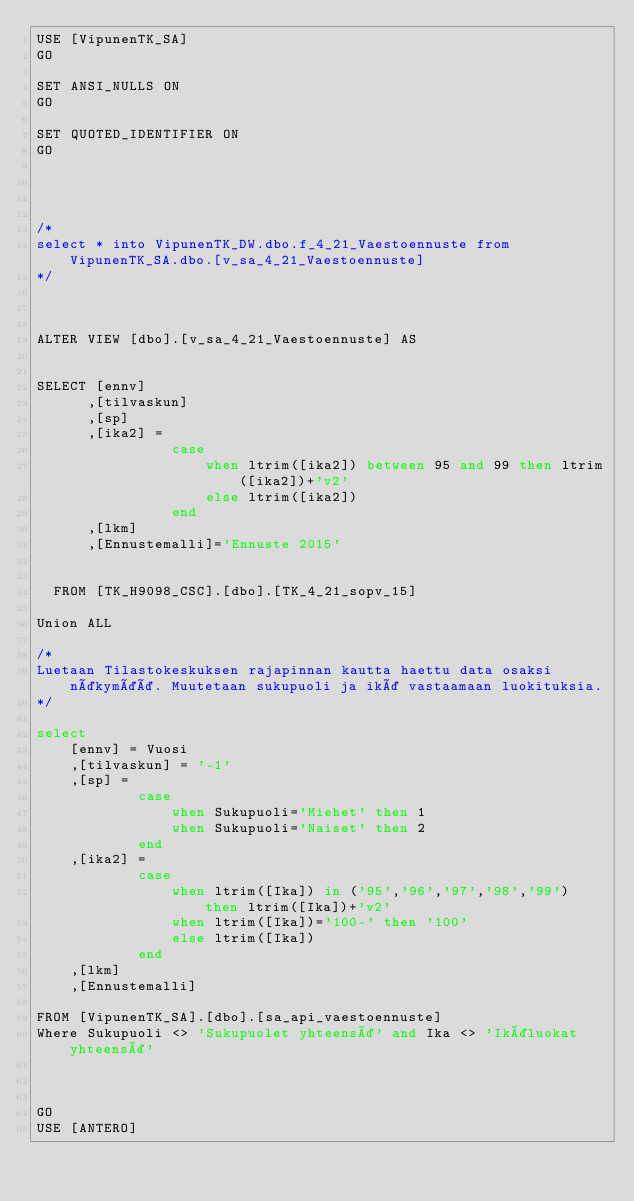Convert code to text. <code><loc_0><loc_0><loc_500><loc_500><_SQL_>USE [VipunenTK_SA]
GO

SET ANSI_NULLS ON
GO

SET QUOTED_IDENTIFIER ON
GO




/*
select * into VipunenTK_DW.dbo.f_4_21_Vaestoennuste from VipunenTK_SA.dbo.[v_sa_4_21_Vaestoennuste]
*/



ALTER VIEW [dbo].[v_sa_4_21_Vaestoennuste] AS


SELECT [ennv]
      ,[tilvaskun]
      ,[sp]
      ,[ika2] = 
				case 
					when ltrim([ika2]) between 95 and 99 then ltrim([ika2])+'v2'
					else ltrim([ika2])
				end
      ,[lkm]
	  ,[Ennustemalli]='Ennuste 2015'

      
  FROM [TK_H9098_CSC].[dbo].[TK_4_21_sopv_15]

Union ALL

/*
Luetaan Tilastokeskuksen rajapinnan kautta haettu data osaksi näkymää. Muutetaan sukupuoli ja ikä vastaamaan luokituksia.
*/

select
	[ennv] = Vuosi
	,[tilvaskun] = '-1'
	,[sp] = 
			case 
				when Sukupuoli='Miehet' then 1 
				when Sukupuoli='Naiset' then 2 
			end
	,[ika2] = 
			case
				when ltrim([Ika]) in ('95','96','97','98','99') then ltrim([Ika])+'v2'
				when ltrim([Ika])='100-' then '100'
				else ltrim([Ika]) 
			end
	,[lkm]
	,[Ennustemalli]

FROM [VipunenTK_SA].[dbo].[sa_api_vaestoennuste]
Where Sukupuoli <> 'Sukupuolet yhteensä' and Ika <> 'Ikäluokat yhteensä'



GO
USE [ANTERO]

</code> 